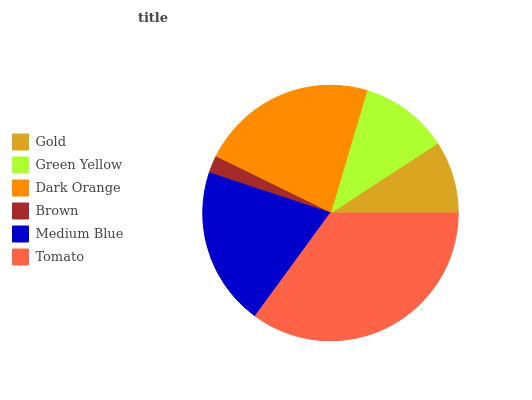Is Brown the minimum?
Answer yes or no. Yes. Is Tomato the maximum?
Answer yes or no. Yes. Is Green Yellow the minimum?
Answer yes or no. No. Is Green Yellow the maximum?
Answer yes or no. No. Is Green Yellow greater than Gold?
Answer yes or no. Yes. Is Gold less than Green Yellow?
Answer yes or no. Yes. Is Gold greater than Green Yellow?
Answer yes or no. No. Is Green Yellow less than Gold?
Answer yes or no. No. Is Medium Blue the high median?
Answer yes or no. Yes. Is Green Yellow the low median?
Answer yes or no. Yes. Is Gold the high median?
Answer yes or no. No. Is Tomato the low median?
Answer yes or no. No. 